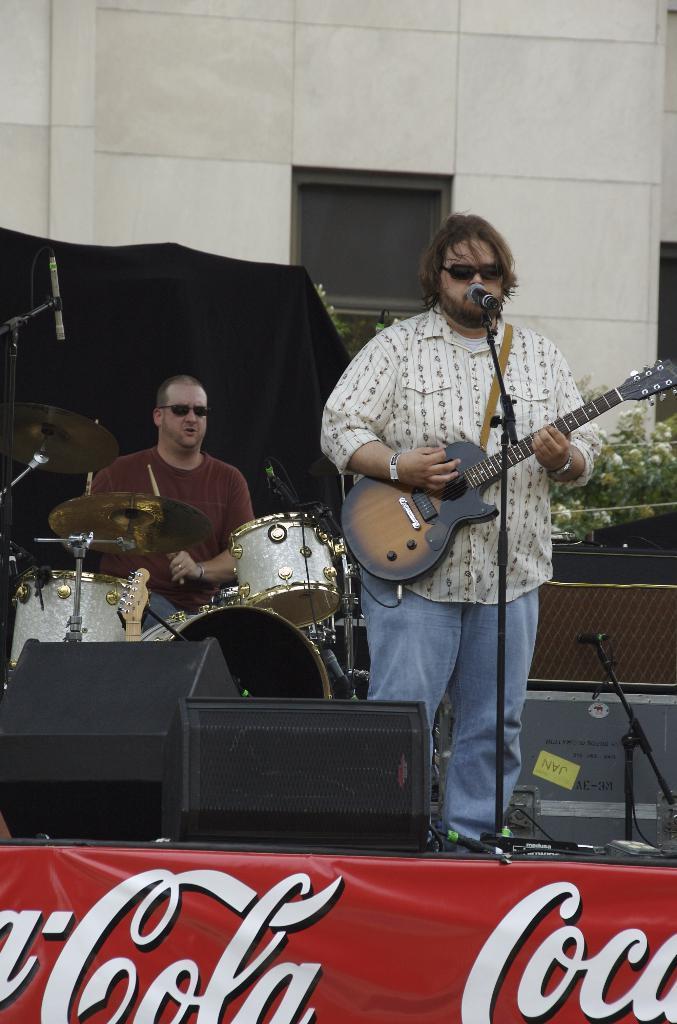Describe this image in one or two sentences. In the middle of the image a man is standing and playing guitar and singing on the microphone. Bottom left side of the image a man is playing drums. Bottom of the image there is a banner. At the top of the image there is a building. In the middle of the image there are some plants. 